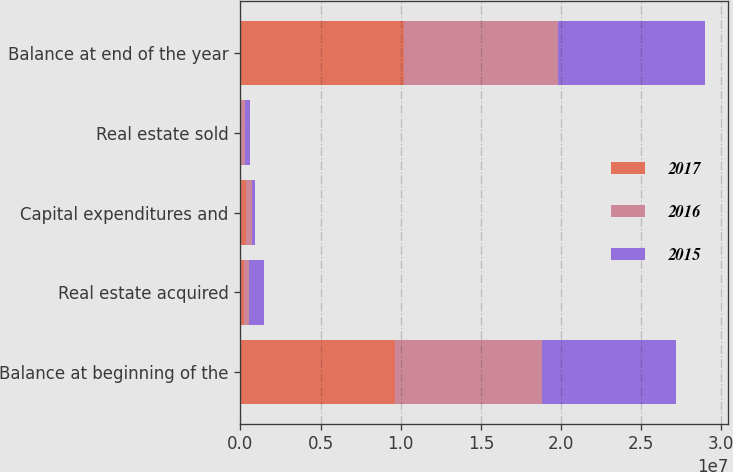<chart> <loc_0><loc_0><loc_500><loc_500><stacked_bar_chart><ecel><fcel>Balance at beginning of the<fcel>Real estate acquired<fcel>Capital expenditures and<fcel>Real estate sold<fcel>Balance at end of the year<nl><fcel>2017<fcel>9.61575e+06<fcel>235993<fcel>369029<fcel>43569<fcel>1.01772e+07<nl><fcel>2016<fcel>9.19028e+06<fcel>324104<fcel>339813<fcel>238440<fcel>9.61575e+06<nl><fcel>2015<fcel>8.38326e+06<fcel>906446<fcel>203183<fcel>301920<fcel>9.19028e+06<nl></chart> 